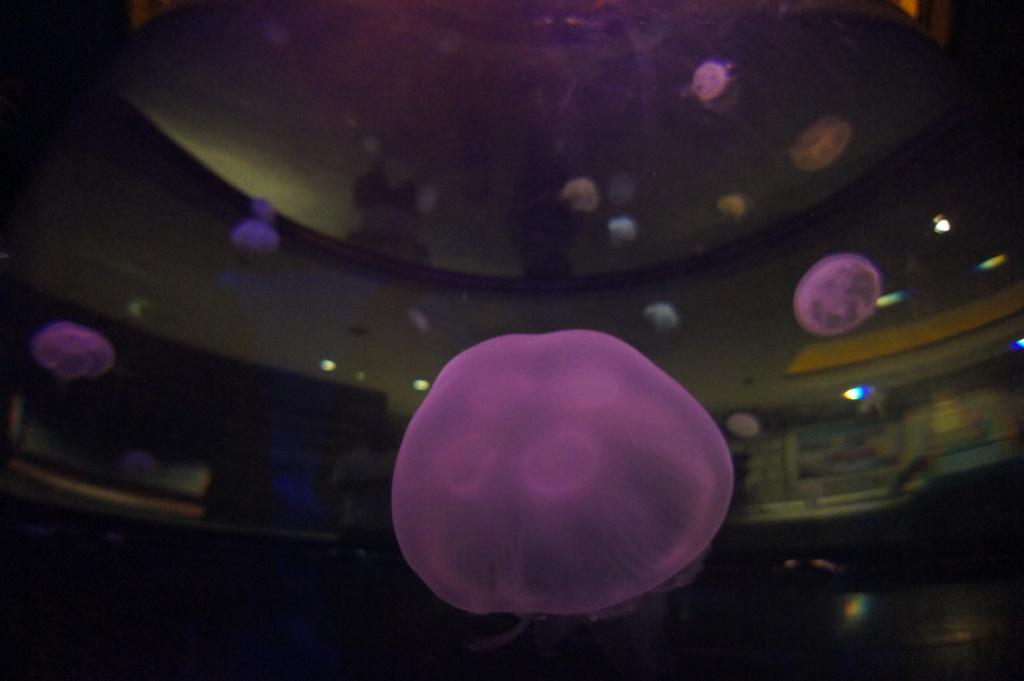What colors are present in the objects in the image? There are objects of violet, white, and brown color in the image. Can you describe the lighting situation in the image? There are lights visible in the image. What is the color of the background in the image? The background of the image is dark. How many trucks are parked in the background of the image? There are no trucks present in the image. Can you describe the behavior of the goose in the image? There is no goose present in the image. 